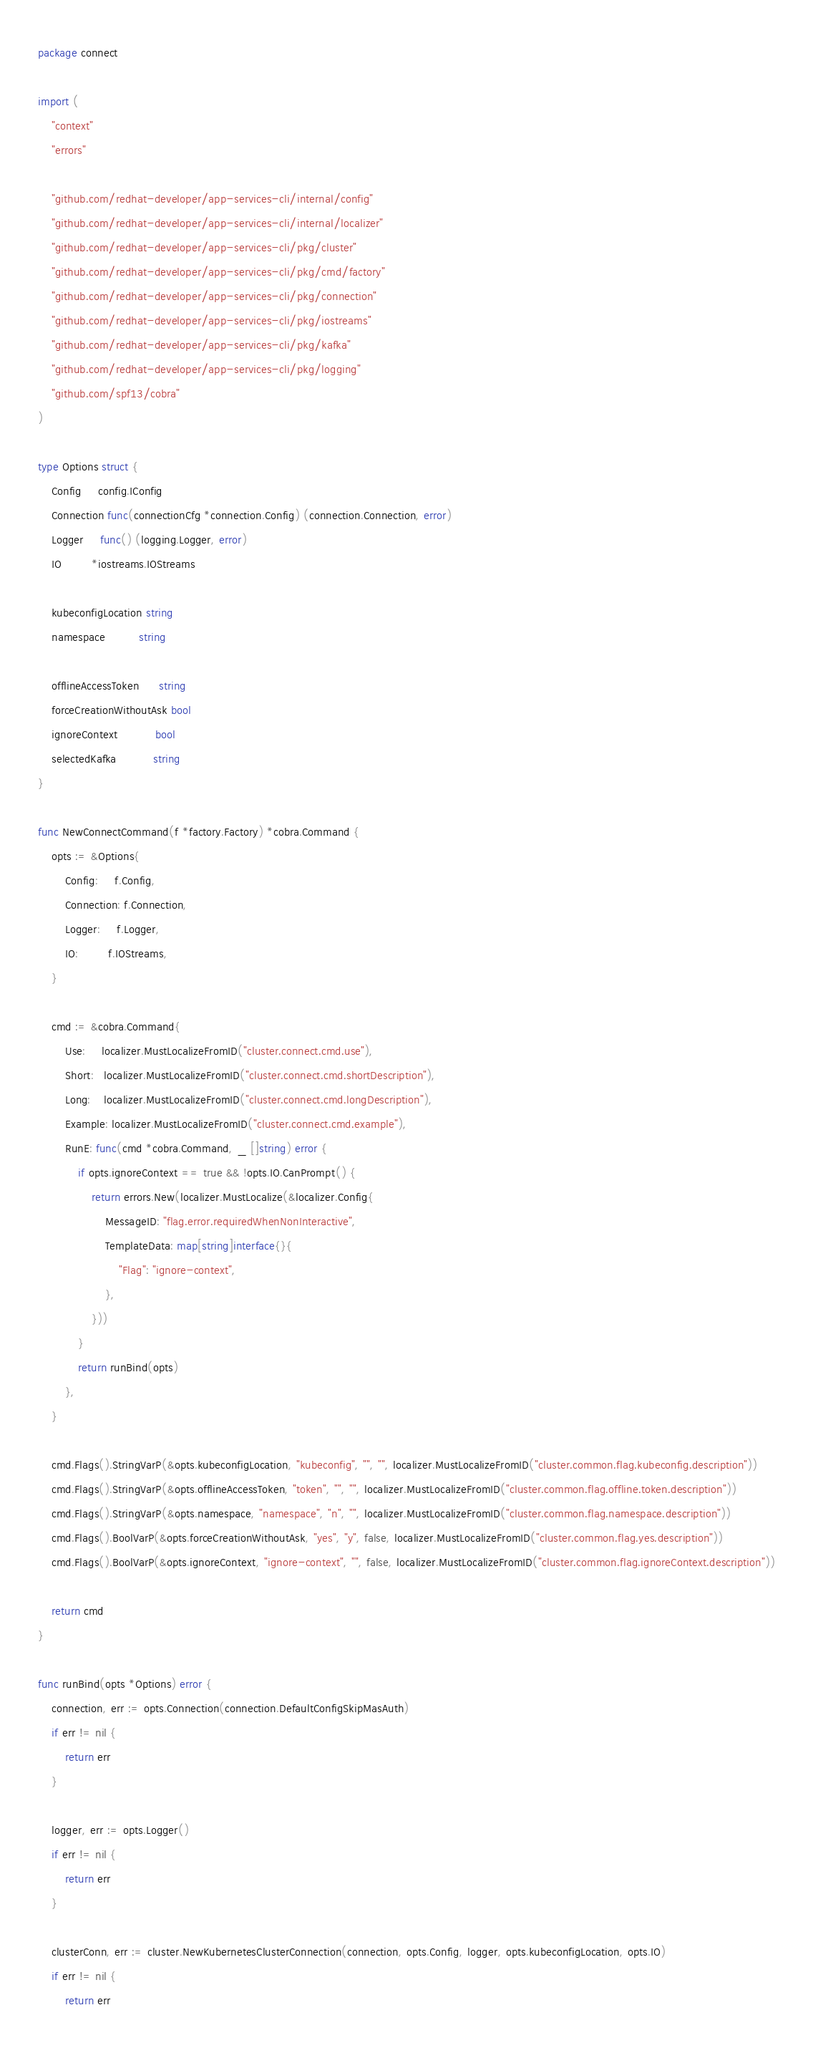<code> <loc_0><loc_0><loc_500><loc_500><_Go_>package connect

import (
	"context"
	"errors"

	"github.com/redhat-developer/app-services-cli/internal/config"
	"github.com/redhat-developer/app-services-cli/internal/localizer"
	"github.com/redhat-developer/app-services-cli/pkg/cluster"
	"github.com/redhat-developer/app-services-cli/pkg/cmd/factory"
	"github.com/redhat-developer/app-services-cli/pkg/connection"
	"github.com/redhat-developer/app-services-cli/pkg/iostreams"
	"github.com/redhat-developer/app-services-cli/pkg/kafka"
	"github.com/redhat-developer/app-services-cli/pkg/logging"
	"github.com/spf13/cobra"
)

type Options struct {
	Config     config.IConfig
	Connection func(connectionCfg *connection.Config) (connection.Connection, error)
	Logger     func() (logging.Logger, error)
	IO         *iostreams.IOStreams

	kubeconfigLocation string
	namespace          string

	offlineAccessToken      string
	forceCreationWithoutAsk bool
	ignoreContext           bool
	selectedKafka           string
}

func NewConnectCommand(f *factory.Factory) *cobra.Command {
	opts := &Options{
		Config:     f.Config,
		Connection: f.Connection,
		Logger:     f.Logger,
		IO:         f.IOStreams,
	}

	cmd := &cobra.Command{
		Use:     localizer.MustLocalizeFromID("cluster.connect.cmd.use"),
		Short:   localizer.MustLocalizeFromID("cluster.connect.cmd.shortDescription"),
		Long:    localizer.MustLocalizeFromID("cluster.connect.cmd.longDescription"),
		Example: localizer.MustLocalizeFromID("cluster.connect.cmd.example"),
		RunE: func(cmd *cobra.Command, _ []string) error {
			if opts.ignoreContext == true && !opts.IO.CanPrompt() {
				return errors.New(localizer.MustLocalize(&localizer.Config{
					MessageID: "flag.error.requiredWhenNonInteractive",
					TemplateData: map[string]interface{}{
						"Flag": "ignore-context",
					},
				}))
			}
			return runBind(opts)
		},
	}

	cmd.Flags().StringVarP(&opts.kubeconfigLocation, "kubeconfig", "", "", localizer.MustLocalizeFromID("cluster.common.flag.kubeconfig.description"))
	cmd.Flags().StringVarP(&opts.offlineAccessToken, "token", "", "", localizer.MustLocalizeFromID("cluster.common.flag.offline.token.description"))
	cmd.Flags().StringVarP(&opts.namespace, "namespace", "n", "", localizer.MustLocalizeFromID("cluster.common.flag.namespace.description"))
	cmd.Flags().BoolVarP(&opts.forceCreationWithoutAsk, "yes", "y", false, localizer.MustLocalizeFromID("cluster.common.flag.yes.description"))
	cmd.Flags().BoolVarP(&opts.ignoreContext, "ignore-context", "", false, localizer.MustLocalizeFromID("cluster.common.flag.ignoreContext.description"))

	return cmd
}

func runBind(opts *Options) error {
	connection, err := opts.Connection(connection.DefaultConfigSkipMasAuth)
	if err != nil {
		return err
	}

	logger, err := opts.Logger()
	if err != nil {
		return err
	}

	clusterConn, err := cluster.NewKubernetesClusterConnection(connection, opts.Config, logger, opts.kubeconfigLocation, opts.IO)
	if err != nil {
		return err</code> 